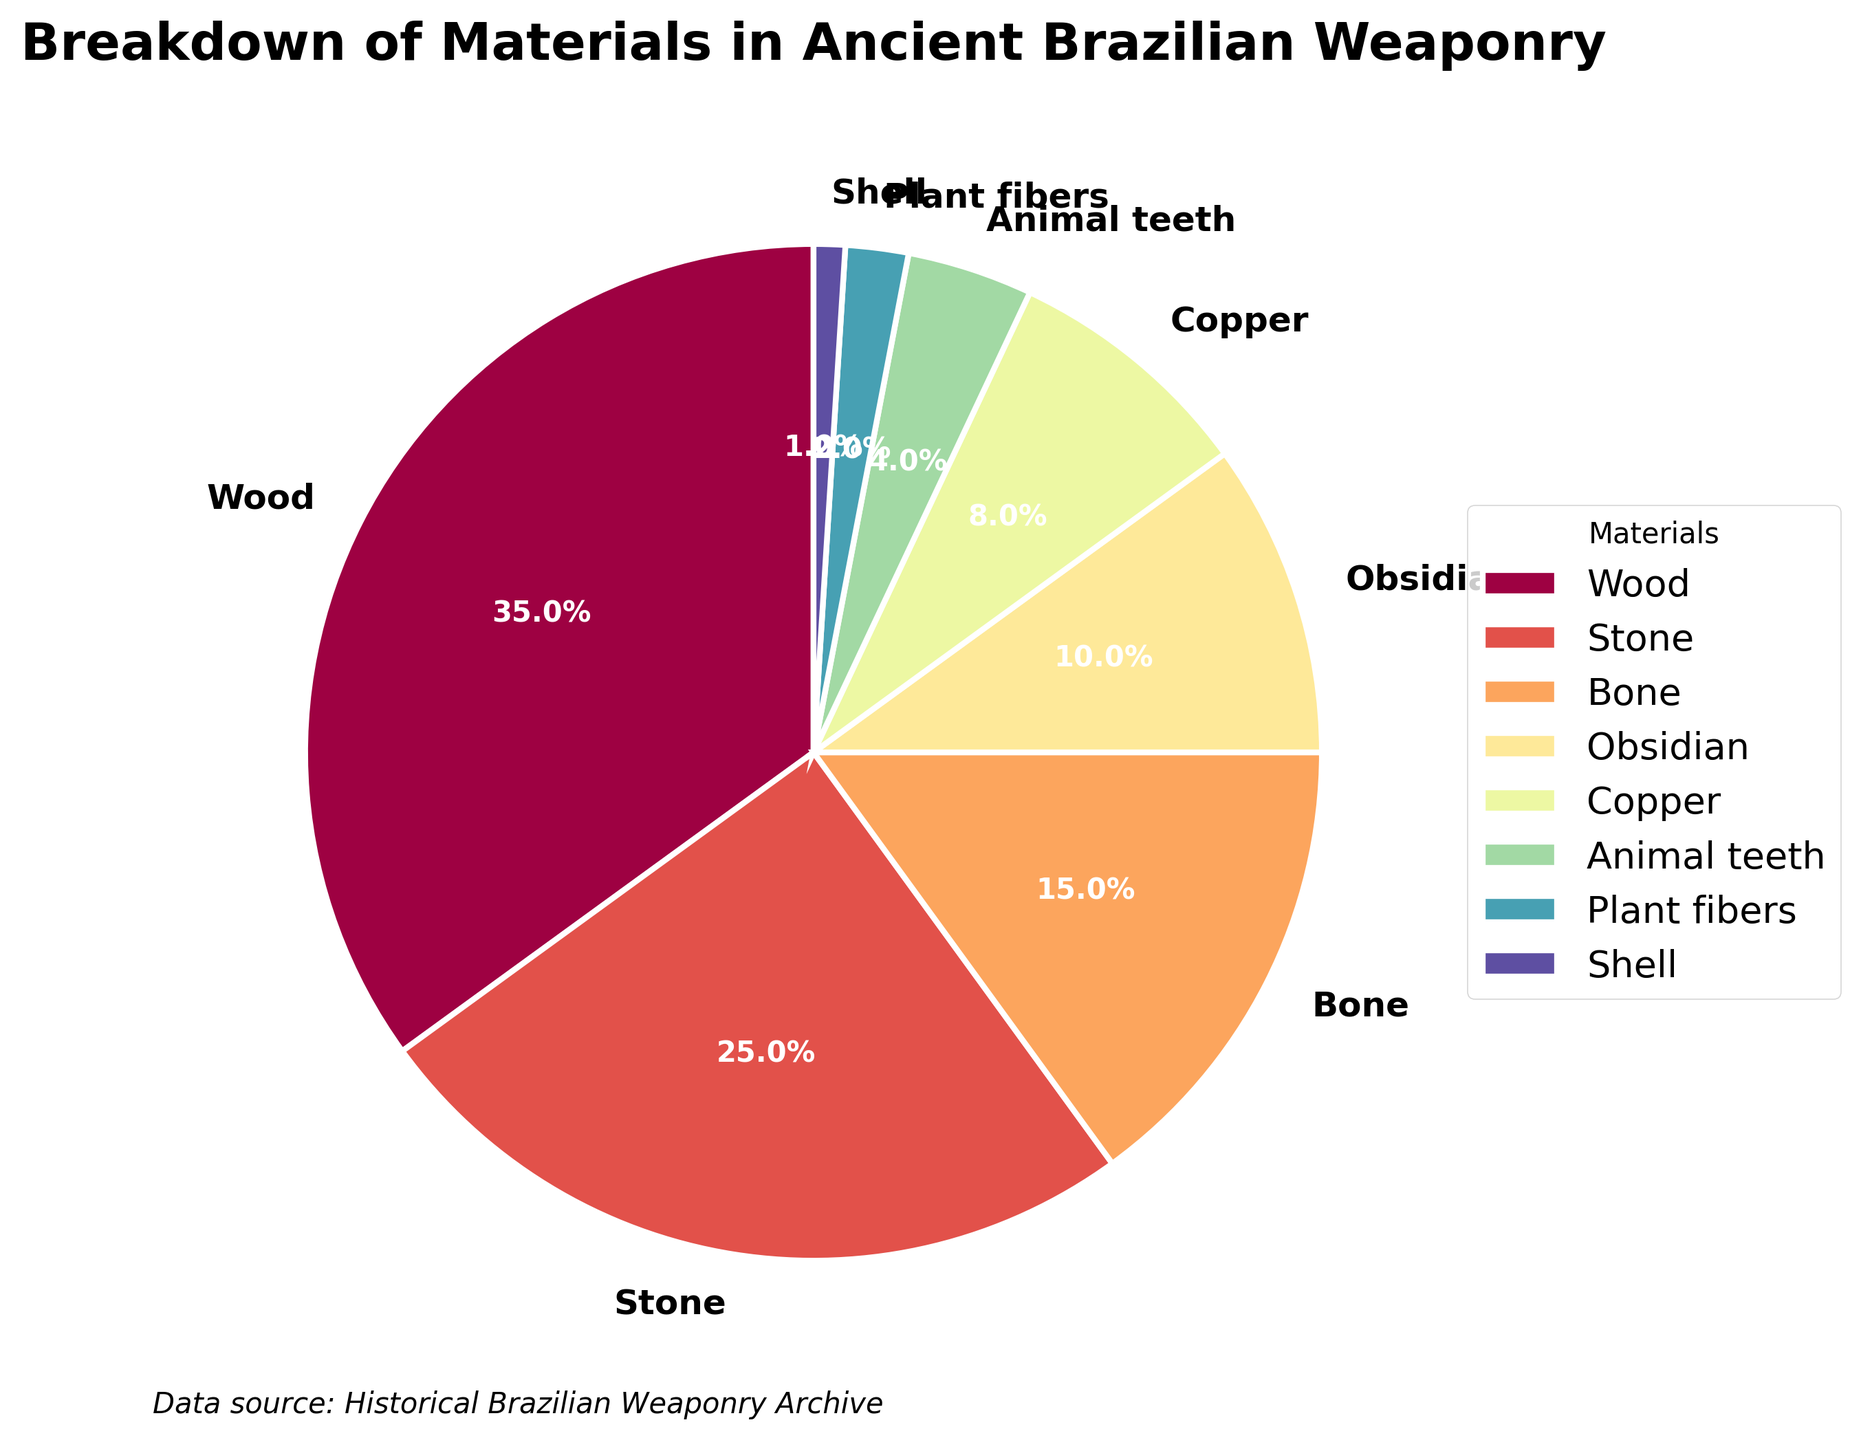What's the material with the highest percentage? By looking at the pie chart, we identify the largest wedge, which is often prominently labeled. Upon inspection, it's clear that "Wood" has the largest segment.
Answer: Wood Which material's percentage is the smallest? Locate the smallest segment in the pie chart visually. The "Shell" slice is the smallest wedge on the chart, pointing out that it has the lowest percentage.
Answer: Shell What's the combined percentage of Stone and Bone materials? Stone is 25%, and Bone is 15%. Add these percentages together to determine the combined total. 25% + 15% = 40%
Answer: 40% How does the percentage of Copper compare to Obsidian? Look at both segments in the pie chart. Copper has 8%, while Obsidian has 10%. So, Obsidian has a higher percentage than Copper.
Answer: Obsidian > Copper Is the combined percentage of Animal teeth and Plant fibers more or less than Bone? First, add the percentages for Animal teeth (4%) and Plant fibers (2%) to get a total of 6%. Then, compare this to Bone, which is 15%. Since 6% is less than 15%, the combined percentage is less.
Answer: Less Which material occupies a middle position based on its percentage? Sort the materials: Shell (1%), Plant fibers (2%), Animal teeth (4%), Copper (8%), Obsidian (10%), Bone (15%), Stone (25%), Wood (35%). Bone, having 15%, lies in the middle.
Answer: Bone If we removed Wood, what would the new total percentage be for the remaining materials? Wood is 35%, so subtract this from 100%: 100% - 35% = 65%. The new total would be 65% for the remaining materials.
Answer: 65% What's the percentage difference between the most common (Wood) and least common (Shell) material? Subtract the percentage of Shell (1%) from Wood's percentage (35%): 35% - 1% = 34%
Answer: 34% How many materials have a percentage greater than 10%? By examining the wedges, we see Wood (35%), Stone (25%), and Bone (15%) are all greater than 10%. There are three such materials.
Answer: 3 What is the similarity in color between Animal teeth and Shell segments? Observe the pie chart's color scheme. Both segments use colors from the same colormap but are distinctly different. The specific colors won't be the same.
Answer: Different 